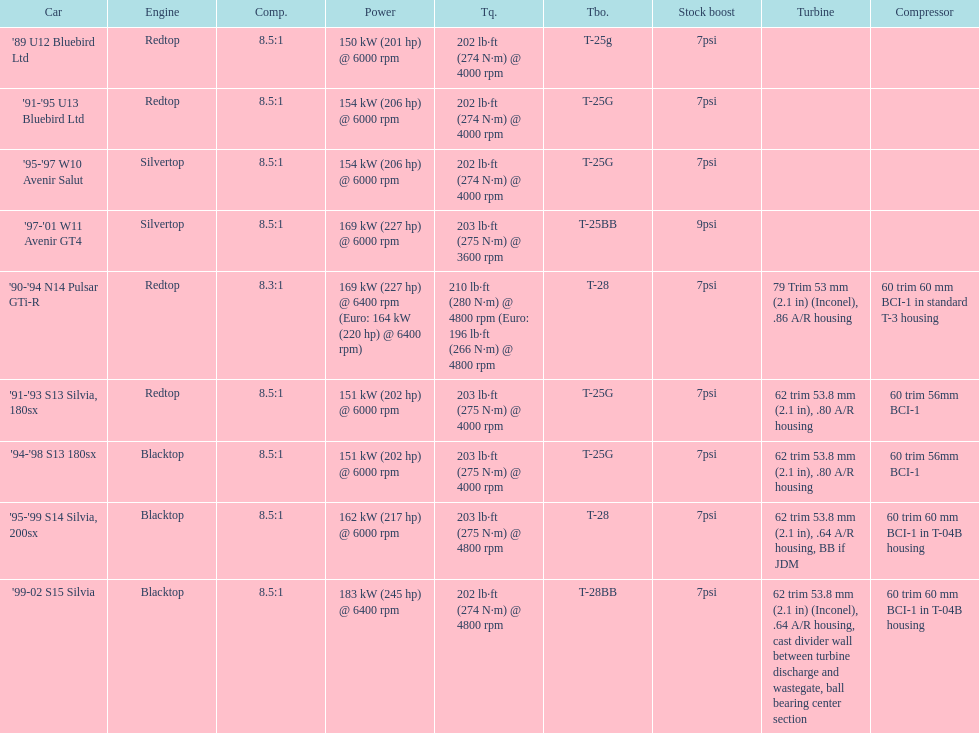Which car's power measured at higher than 6000 rpm? '90-'94 N14 Pulsar GTi-R, '99-02 S15 Silvia. 